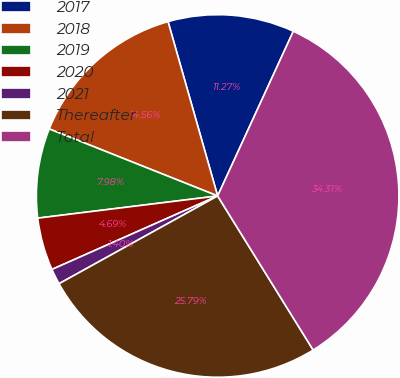Convert chart. <chart><loc_0><loc_0><loc_500><loc_500><pie_chart><fcel>2017<fcel>2018<fcel>2019<fcel>2020<fcel>2021<fcel>Thereafter<fcel>Total<nl><fcel>11.27%<fcel>14.56%<fcel>7.98%<fcel>4.69%<fcel>1.4%<fcel>25.79%<fcel>34.31%<nl></chart> 